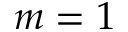<formula> <loc_0><loc_0><loc_500><loc_500>m = 1</formula> 